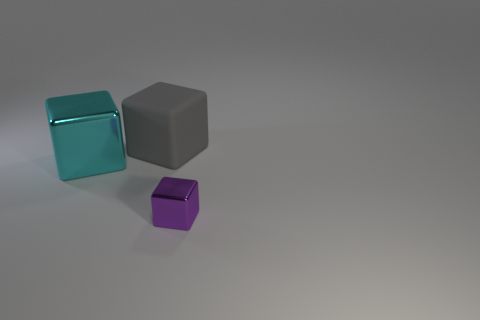Is there any other thing that has the same size as the purple shiny thing?
Offer a very short reply. No. There is a large object that is right of the cyan metal cube; is it the same shape as the small metallic thing?
Your answer should be compact. Yes. Are any large gray rubber cubes visible?
Your answer should be compact. Yes. The object that is behind the shiny block behind the metallic thing in front of the cyan thing is what color?
Give a very brief answer. Gray. Are there the same number of large gray matte cubes that are in front of the tiny cube and small purple metallic cubes that are to the right of the large cyan thing?
Offer a terse response. No. Are there any small matte spheres of the same color as the rubber block?
Provide a succinct answer. No. There is a big thing in front of the gray rubber cube; what is its shape?
Provide a short and direct response. Cube. The rubber block has what color?
Make the answer very short. Gray. What color is the other block that is the same material as the cyan cube?
Make the answer very short. Purple. What number of cyan blocks have the same material as the tiny purple cube?
Provide a short and direct response. 1. 